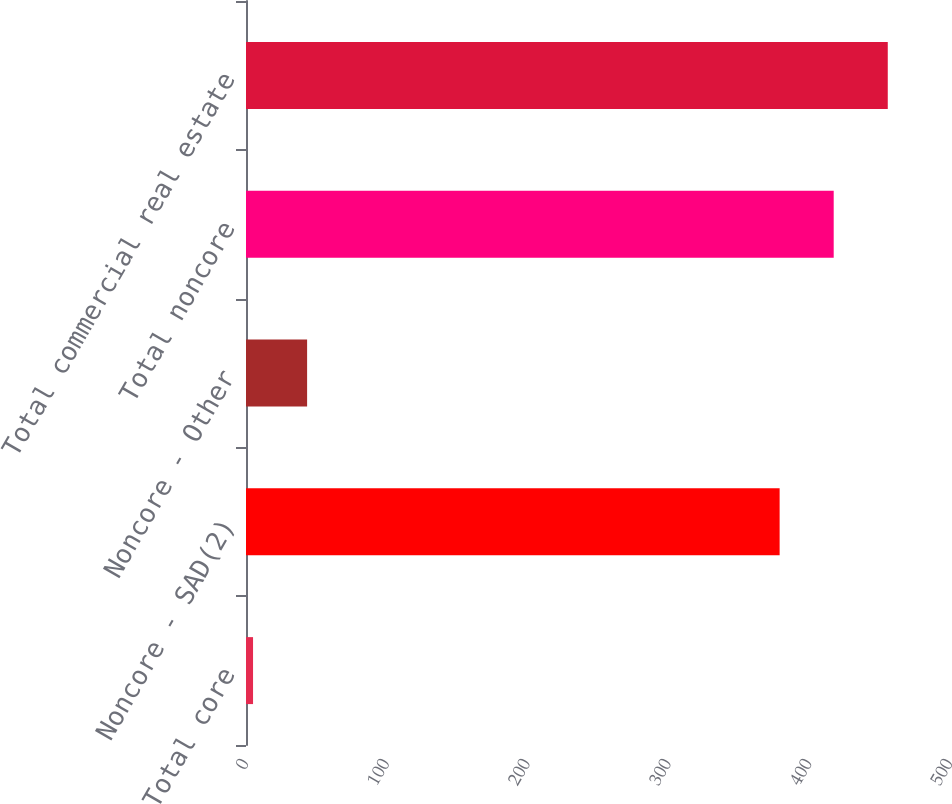Convert chart to OTSL. <chart><loc_0><loc_0><loc_500><loc_500><bar_chart><fcel>Total core<fcel>Noncore - SAD(2)<fcel>Noncore - Other<fcel>Total noncore<fcel>Total commercial real estate<nl><fcel>5<fcel>379<fcel>43.4<fcel>417.4<fcel>455.8<nl></chart> 